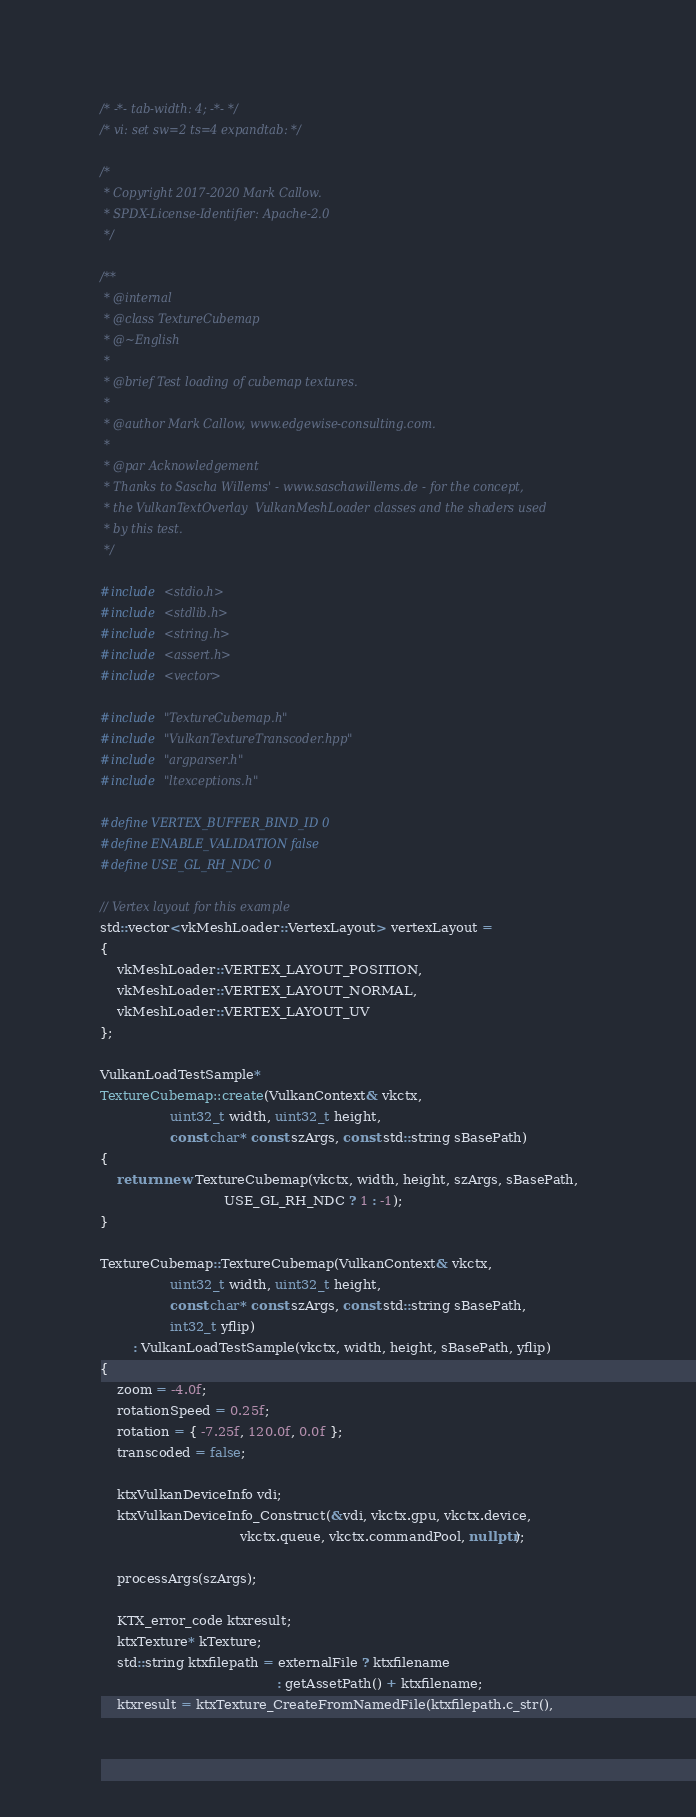<code> <loc_0><loc_0><loc_500><loc_500><_C++_>/* -*- tab-width: 4; -*- */
/* vi: set sw=2 ts=4 expandtab: */

/*
 * Copyright 2017-2020 Mark Callow.
 * SPDX-License-Identifier: Apache-2.0
 */

/**
 * @internal
 * @class TextureCubemap
 * @~English
 *
 * @brief Test loading of cubemap textures.
 *
 * @author Mark Callow, www.edgewise-consulting.com.
 *
 * @par Acknowledgement
 * Thanks to Sascha Willems' - www.saschawillems.de - for the concept,
 * the VulkanTextOverlay  VulkanMeshLoader classes and the shaders used
 * by this test.
 */

#include <stdio.h>
#include <stdlib.h>
#include <string.h>
#include <assert.h>
#include <vector>

#include "TextureCubemap.h"
#include "VulkanTextureTranscoder.hpp"
#include "argparser.h"
#include "ltexceptions.h"

#define VERTEX_BUFFER_BIND_ID 0
#define ENABLE_VALIDATION false
#define USE_GL_RH_NDC 0

// Vertex layout for this example
std::vector<vkMeshLoader::VertexLayout> vertexLayout =
{
    vkMeshLoader::VERTEX_LAYOUT_POSITION,
    vkMeshLoader::VERTEX_LAYOUT_NORMAL,
    vkMeshLoader::VERTEX_LAYOUT_UV
};

VulkanLoadTestSample*
TextureCubemap::create(VulkanContext& vkctx,
                 uint32_t width, uint32_t height,
                 const char* const szArgs, const std::string sBasePath)
{
    return new TextureCubemap(vkctx, width, height, szArgs, sBasePath,
                              USE_GL_RH_NDC ? 1 : -1);
}

TextureCubemap::TextureCubemap(VulkanContext& vkctx,
                 uint32_t width, uint32_t height,
                 const char* const szArgs, const std::string sBasePath,
                 int32_t yflip)
        : VulkanLoadTestSample(vkctx, width, height, sBasePath, yflip)
{
    zoom = -4.0f;
    rotationSpeed = 0.25f;
    rotation = { -7.25f, 120.0f, 0.0f };
    transcoded = false;

    ktxVulkanDeviceInfo vdi;
    ktxVulkanDeviceInfo_Construct(&vdi, vkctx.gpu, vkctx.device,
                                  vkctx.queue, vkctx.commandPool, nullptr);

    processArgs(szArgs);

    KTX_error_code ktxresult;
    ktxTexture* kTexture;
    std::string ktxfilepath = externalFile ? ktxfilename
                                           : getAssetPath() + ktxfilename;
    ktxresult = ktxTexture_CreateFromNamedFile(ktxfilepath.c_str(),</code> 